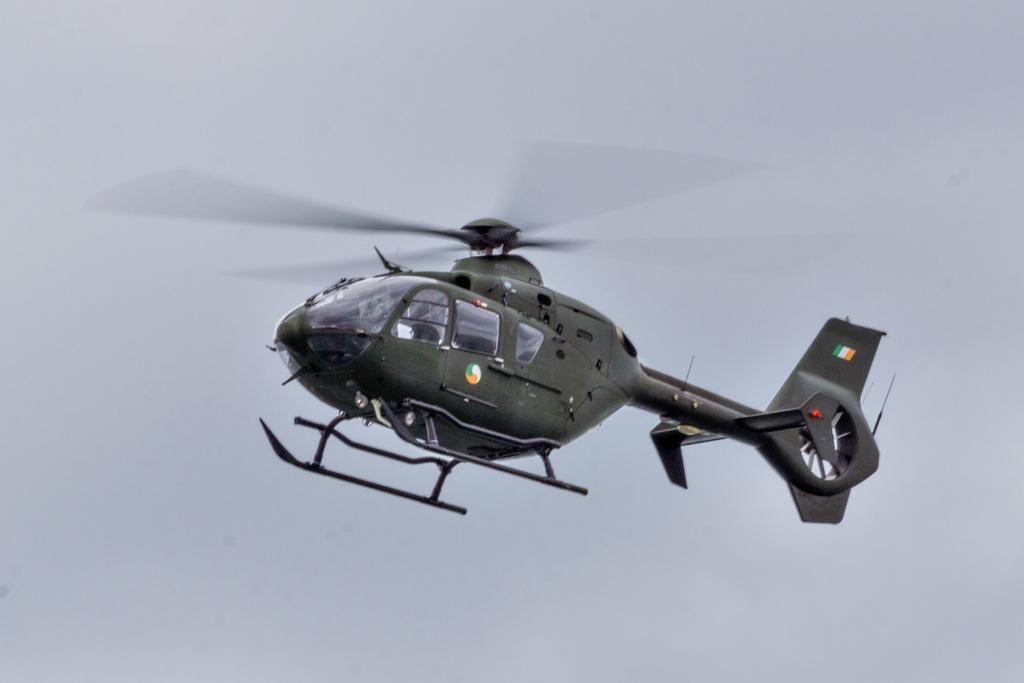Please provide a concise description of this image. In this image t In this image there is a helicopter in the air. In the background of the image there is sky. 